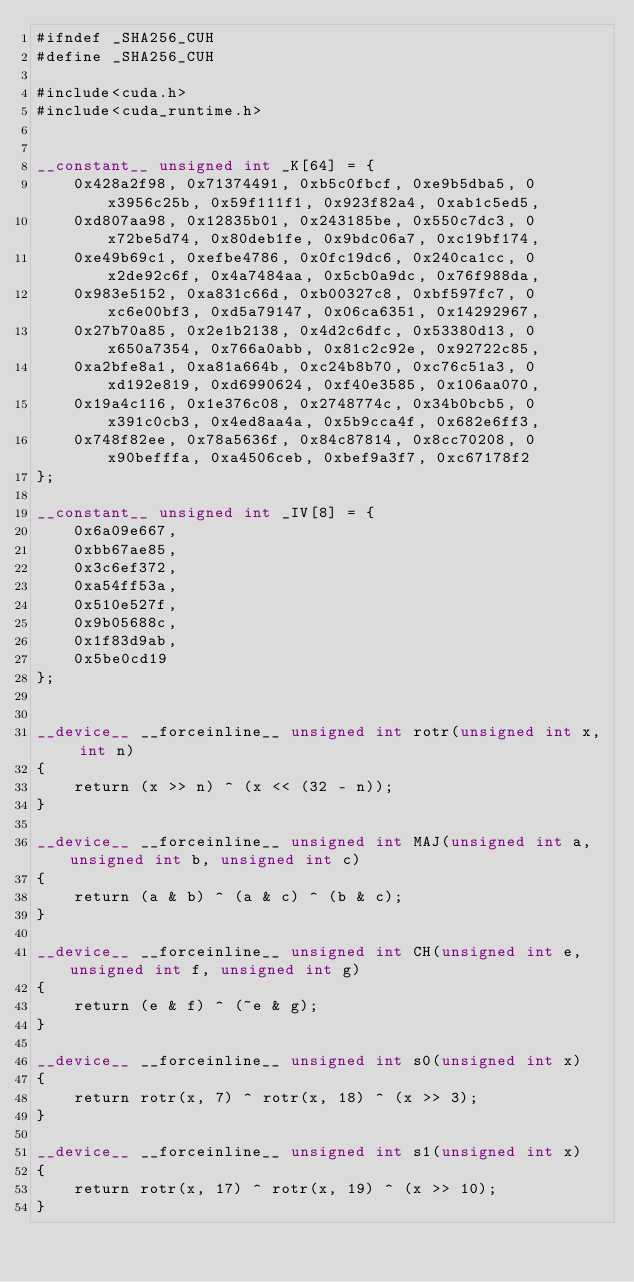Convert code to text. <code><loc_0><loc_0><loc_500><loc_500><_Cuda_>#ifndef _SHA256_CUH
#define _SHA256_CUH

#include<cuda.h>
#include<cuda_runtime.h>


__constant__ unsigned int _K[64] = {
	0x428a2f98, 0x71374491, 0xb5c0fbcf, 0xe9b5dba5, 0x3956c25b, 0x59f111f1, 0x923f82a4, 0xab1c5ed5,
	0xd807aa98, 0x12835b01, 0x243185be, 0x550c7dc3, 0x72be5d74, 0x80deb1fe, 0x9bdc06a7, 0xc19bf174,
	0xe49b69c1, 0xefbe4786, 0x0fc19dc6, 0x240ca1cc, 0x2de92c6f, 0x4a7484aa, 0x5cb0a9dc, 0x76f988da,
	0x983e5152, 0xa831c66d, 0xb00327c8, 0xbf597fc7, 0xc6e00bf3, 0xd5a79147, 0x06ca6351, 0x14292967,
	0x27b70a85, 0x2e1b2138, 0x4d2c6dfc, 0x53380d13, 0x650a7354, 0x766a0abb, 0x81c2c92e, 0x92722c85,
	0xa2bfe8a1, 0xa81a664b, 0xc24b8b70, 0xc76c51a3, 0xd192e819, 0xd6990624, 0xf40e3585, 0x106aa070,
	0x19a4c116, 0x1e376c08, 0x2748774c, 0x34b0bcb5, 0x391c0cb3, 0x4ed8aa4a, 0x5b9cca4f, 0x682e6ff3,
	0x748f82ee, 0x78a5636f, 0x84c87814, 0x8cc70208, 0x90befffa, 0xa4506ceb, 0xbef9a3f7, 0xc67178f2
};

__constant__ unsigned int _IV[8] = {
	0x6a09e667,
	0xbb67ae85,
	0x3c6ef372,
	0xa54ff53a,
	0x510e527f,
	0x9b05688c,
	0x1f83d9ab,
	0x5be0cd19
};


__device__ __forceinline__ unsigned int rotr(unsigned int x, int n)
{
	return (x >> n) ^ (x << (32 - n));
}

__device__ __forceinline__ unsigned int MAJ(unsigned int a, unsigned int b, unsigned int c)
{
	return (a & b) ^ (a & c) ^ (b & c);
}

__device__ __forceinline__ unsigned int CH(unsigned int e, unsigned int f, unsigned int g)
{
	return (e & f) ^ (~e & g);
}

__device__ __forceinline__ unsigned int s0(unsigned int x)
{
	return rotr(x, 7) ^ rotr(x, 18) ^ (x >> 3);
}

__device__ __forceinline__ unsigned int s1(unsigned int x)
{
	return rotr(x, 17) ^ rotr(x, 19) ^ (x >> 10);
}

</code> 